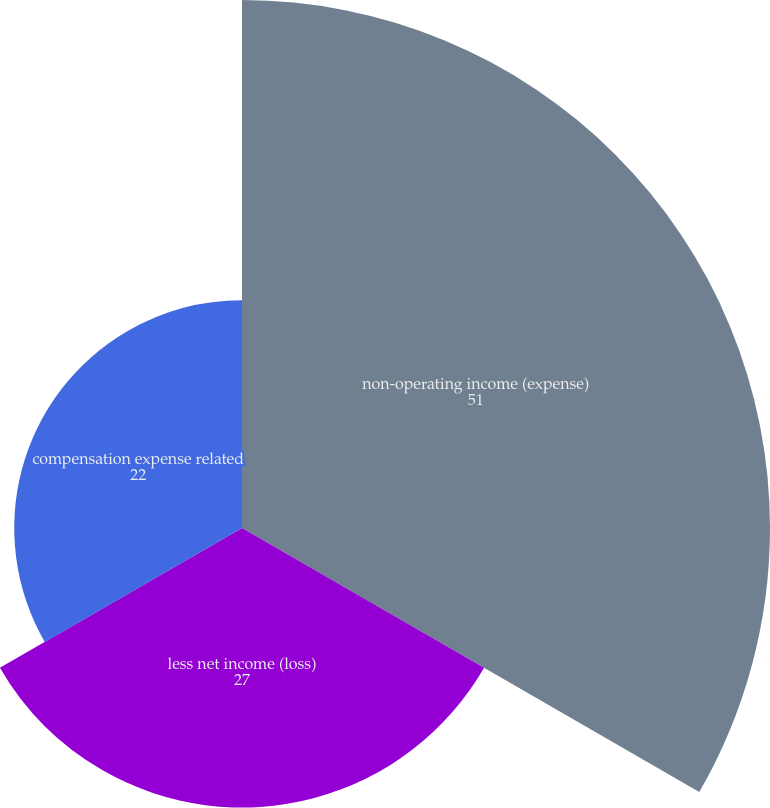Convert chart. <chart><loc_0><loc_0><loc_500><loc_500><pie_chart><fcel>non-operating income (expense)<fcel>less net income (loss)<fcel>compensation expense related<nl><fcel>51.0%<fcel>27.0%<fcel>22.0%<nl></chart> 